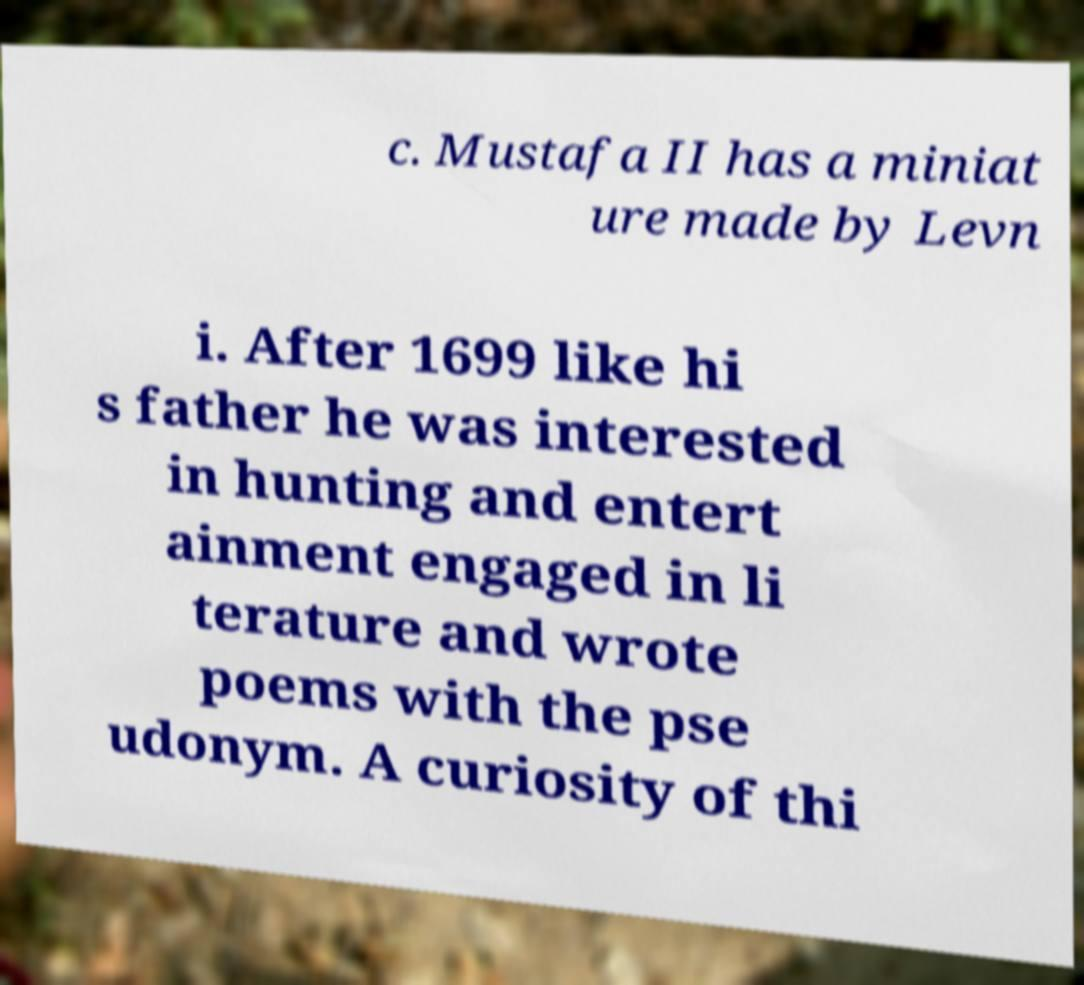Could you extract and type out the text from this image? c. Mustafa II has a miniat ure made by Levn i. After 1699 like hi s father he was interested in hunting and entert ainment engaged in li terature and wrote poems with the pse udonym. A curiosity of thi 